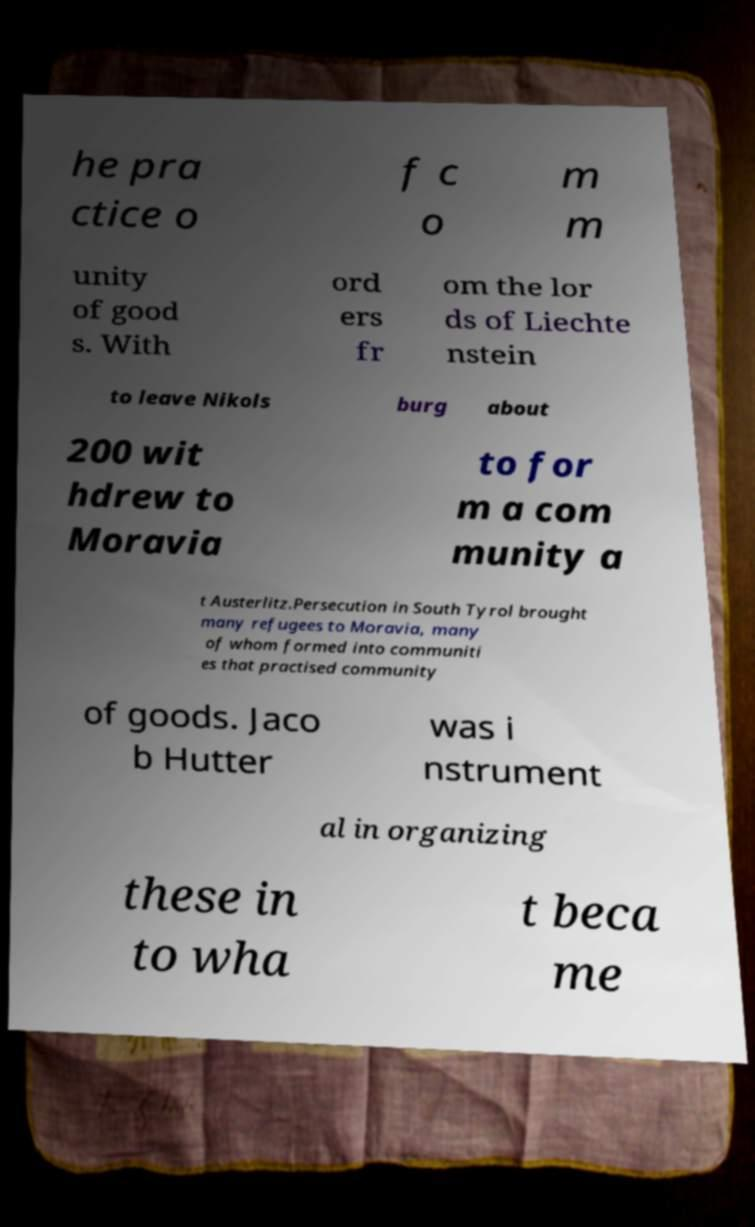What messages or text are displayed in this image? I need them in a readable, typed format. he pra ctice o f c o m m unity of good s. With ord ers fr om the lor ds of Liechte nstein to leave Nikols burg about 200 wit hdrew to Moravia to for m a com munity a t Austerlitz.Persecution in South Tyrol brought many refugees to Moravia, many of whom formed into communiti es that practised community of goods. Jaco b Hutter was i nstrument al in organizing these in to wha t beca me 